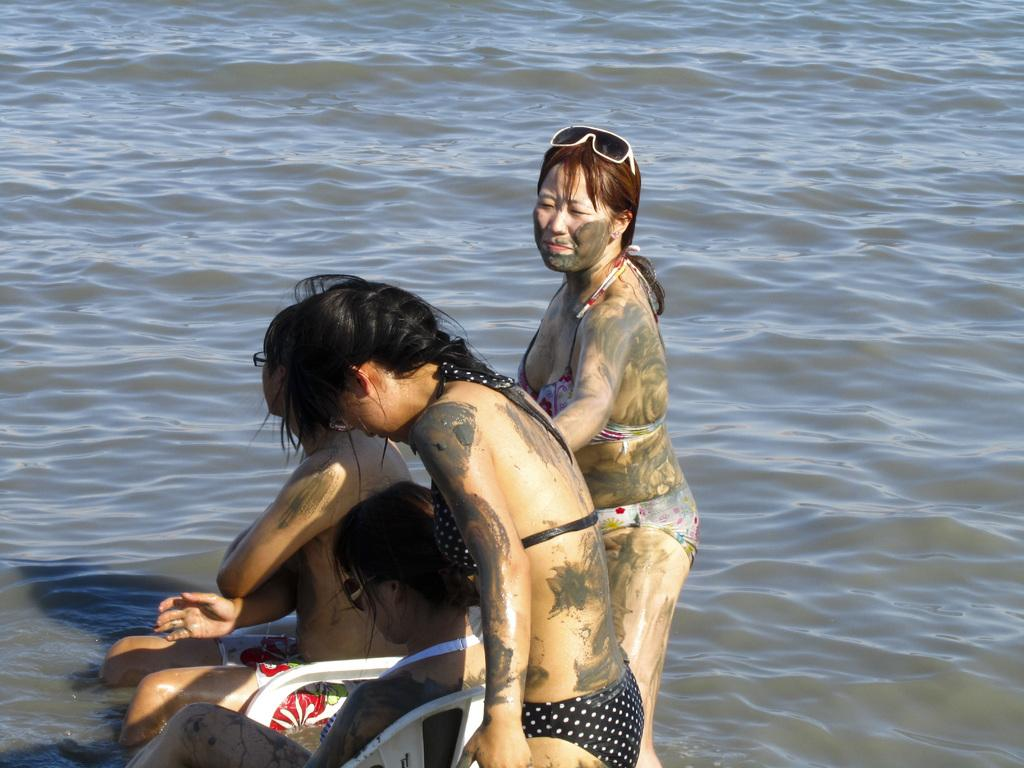What is visible in the image? There is water visible in the image. How many women are in the image? There are four women in the image. What are the positions of the women in the image? Two of the women are standing, and two of the women are sitting on chairs. What type of advice can be heard from the women in the image? There is no dialogue or conversation depicted in the image, so it is not possible to determine what advice might be given. 